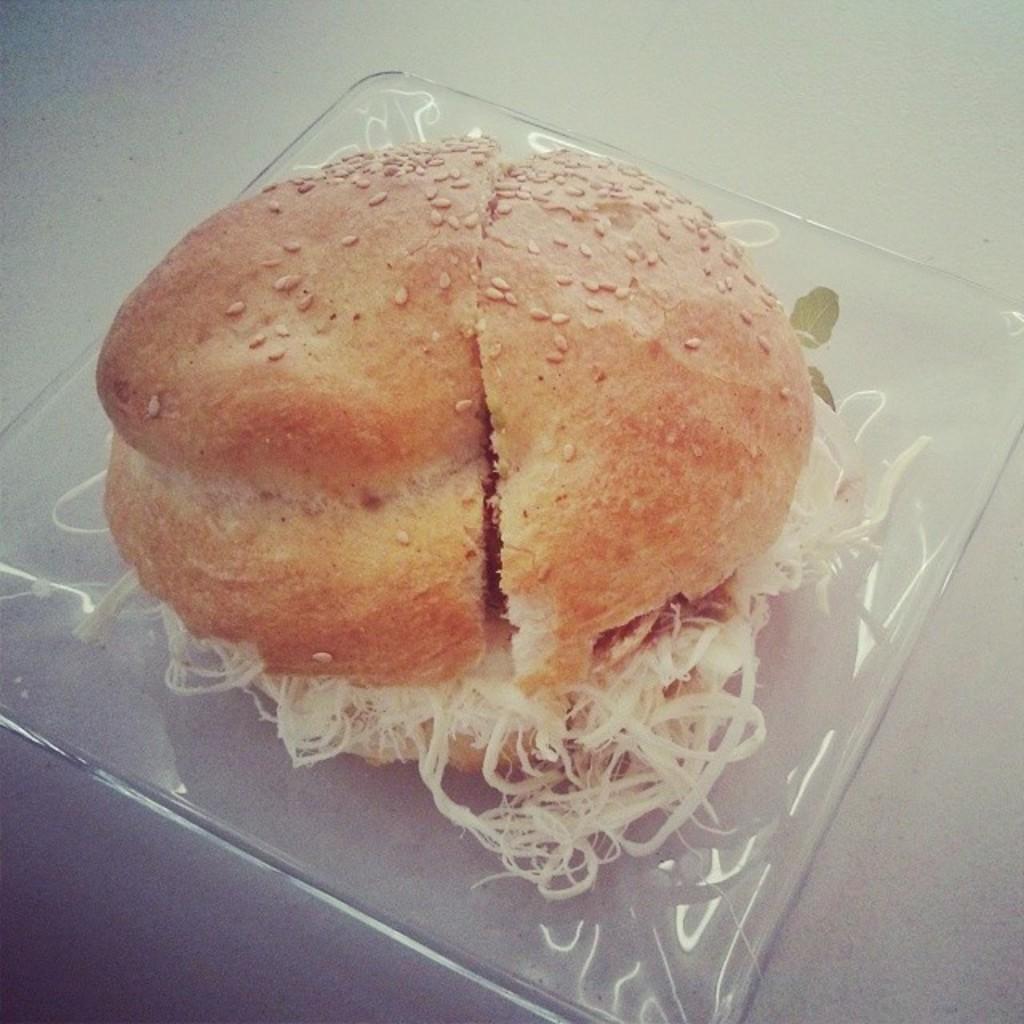Could you give a brief overview of what you see in this image? In this picture we can see burger. 